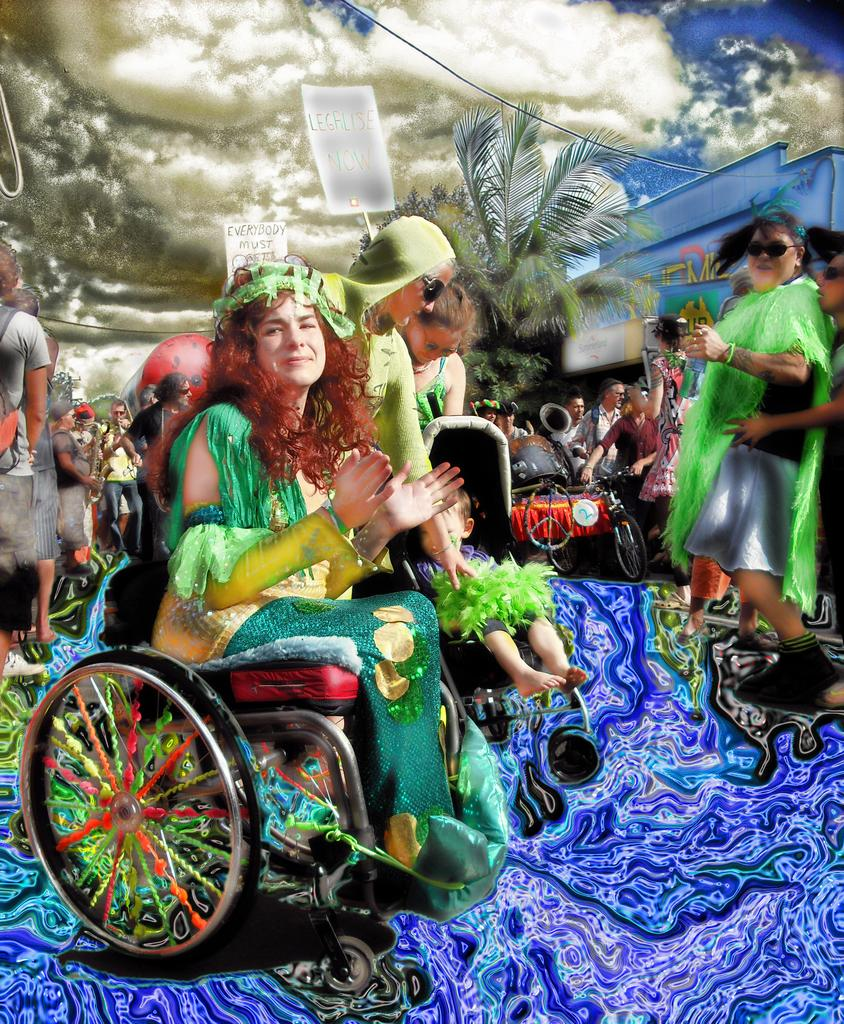What is the main subject of the image? There is a painting in the image. Can you describe the woman in the image? There is a woman sitting on a wheelchair in the image. What else can be seen in the image besides the painting and the woman? There is a group of people standing in the image, as well as trees. How would you describe the weather in the image? The sky is cloudy in the image. What type of cherries are being pulled by the governor in the image? There is no governor or cherries present in the image. How does the woman in the wheelchair pull the cherries in the image? The woman in the wheelchair is not pulling cherries in the image; she is simply sitting on the wheelchair. 